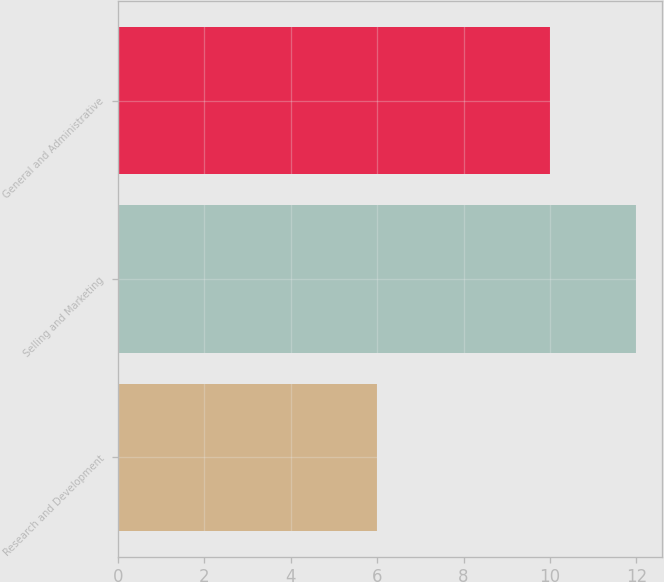Convert chart to OTSL. <chart><loc_0><loc_0><loc_500><loc_500><bar_chart><fcel>Research and Development<fcel>Selling and Marketing<fcel>General and Administrative<nl><fcel>6<fcel>12<fcel>10<nl></chart> 